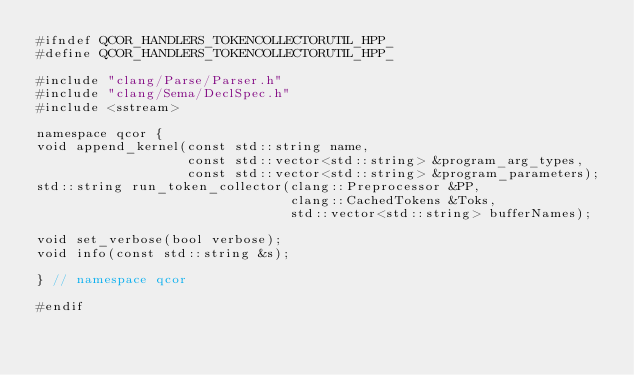<code> <loc_0><loc_0><loc_500><loc_500><_C++_>#ifndef QCOR_HANDLERS_TOKENCOLLECTORUTIL_HPP_
#define QCOR_HANDLERS_TOKENCOLLECTORUTIL_HPP_

#include "clang/Parse/Parser.h"
#include "clang/Sema/DeclSpec.h"
#include <sstream>

namespace qcor {
void append_kernel(const std::string name,
                   const std::vector<std::string> &program_arg_types,
                   const std::vector<std::string> &program_parameters);
std::string run_token_collector(clang::Preprocessor &PP,
                                clang::CachedTokens &Toks,
                                std::vector<std::string> bufferNames);

void set_verbose(bool verbose);
void info(const std::string &s);

} // namespace qcor

#endif</code> 